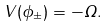Convert formula to latex. <formula><loc_0><loc_0><loc_500><loc_500>V ( \phi _ { \pm } ) = - \Omega .</formula> 